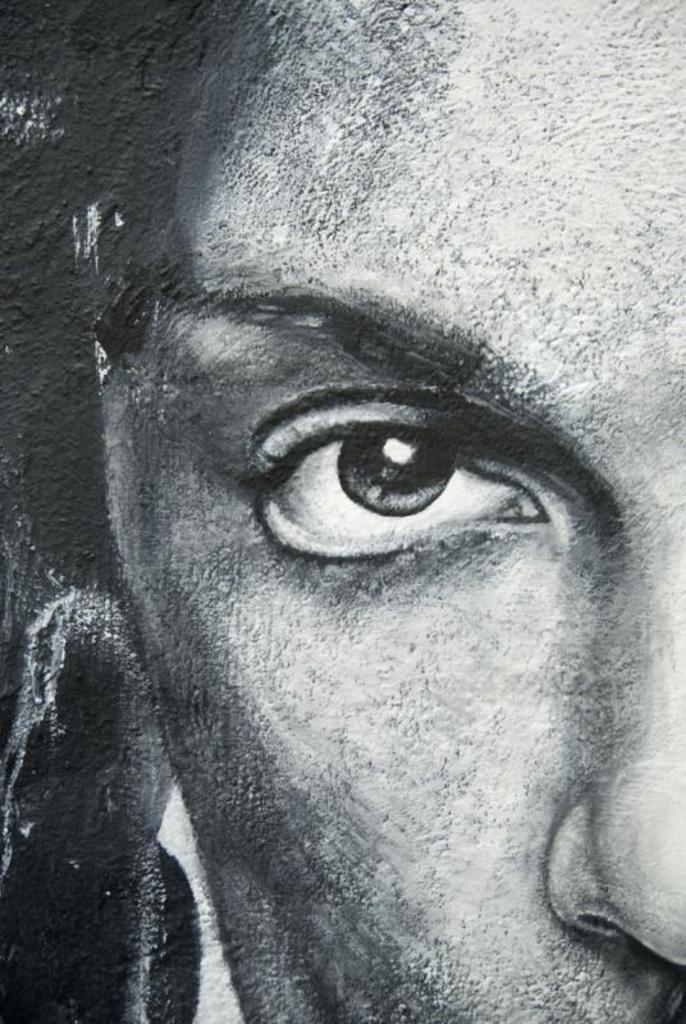What is the main subject of the image? There is a painting of a person in the image. How many gloves can be seen on the person in the painting? There are no gloves visible in the painting; it only depicts a person. 